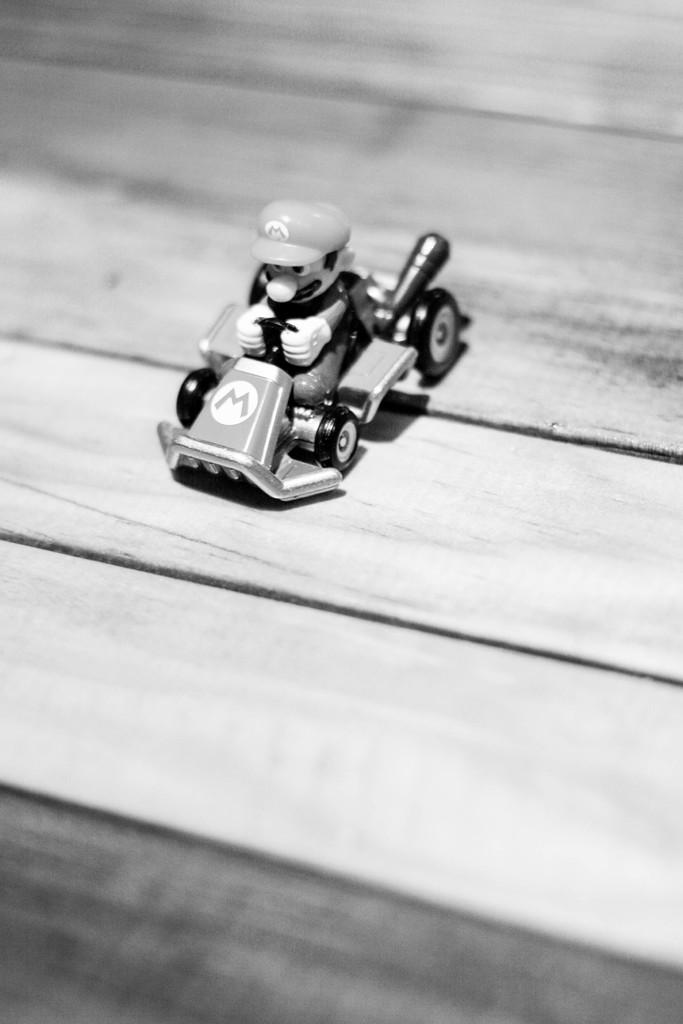What is the main subject of the image? The main subject of the image is a toy vehicle. What is the toy vehicle doing in the image? The toy vehicle is riding a man. What is the surface on which the toy vehicle and the man are situated? Both the toy vehicle and the man are on a wooden plank. What type of veil can be seen covering the toy vehicle in the image? There is no veil present in the image, as it features a toy vehicle riding a man on a wooden plank. What type of food is being served on the wooden plank in the image? There is no food present in the image; it features a toy vehicle riding a man on a wooden plank. 